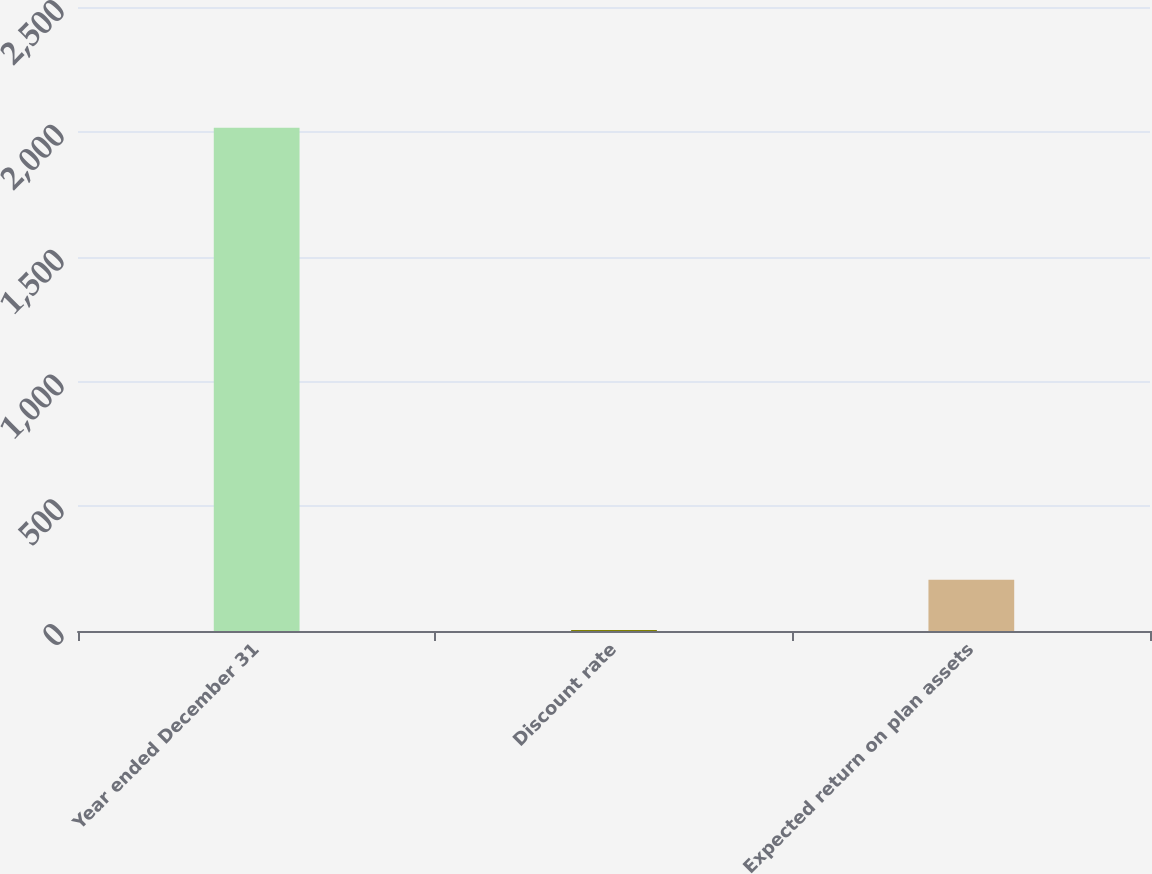Convert chart. <chart><loc_0><loc_0><loc_500><loc_500><bar_chart><fcel>Year ended December 31<fcel>Discount rate<fcel>Expected return on plan assets<nl><fcel>2016<fcel>3.75<fcel>204.98<nl></chart> 